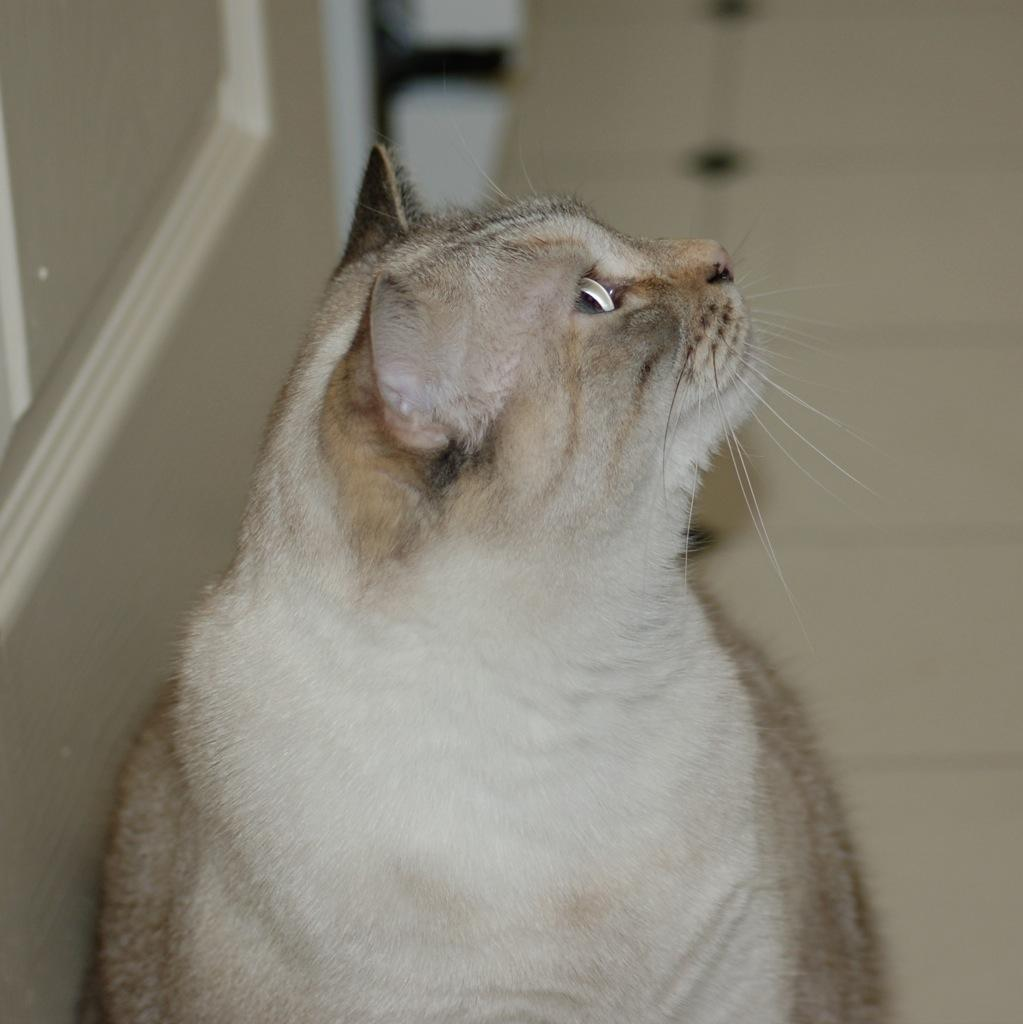What is the main subject in the foreground of the image? There is a cat in the foreground of the image. Where is the cat located? The cat is on the floor. What direction is the cat looking in? The cat is looking upwards. What can be seen in the background of the image? There is a floor and a wall in the background of the image. What type of celery is the cat eating in the image? There is no celery present in the image; the cat is not eating anything. How many slices of bread are on the floor next to the cat? There are no slices of bread present in the image. 